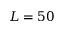<formula> <loc_0><loc_0><loc_500><loc_500>L = 5 0</formula> 